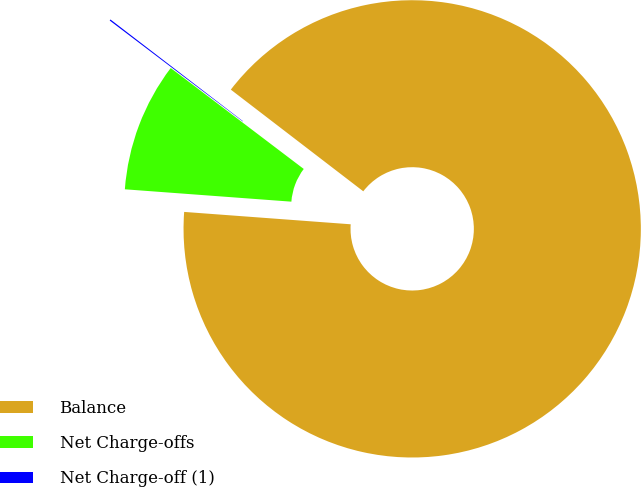Convert chart to OTSL. <chart><loc_0><loc_0><loc_500><loc_500><pie_chart><fcel>Balance<fcel>Net Charge-offs<fcel>Net Charge-off (1)<nl><fcel>90.76%<fcel>9.15%<fcel>0.09%<nl></chart> 